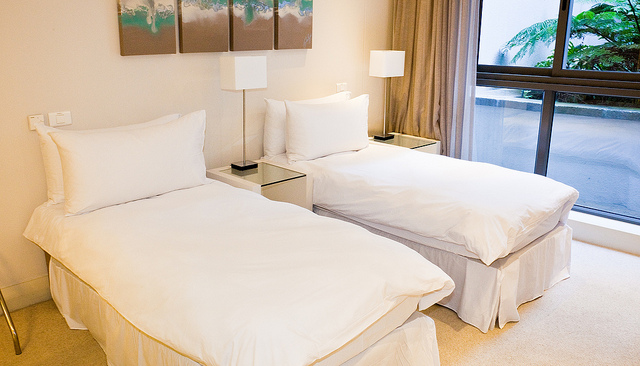Are there any signs of personal items or occupancy in this room? The room appears devoid of personal items, indicating it might be a display room, a hotel room awaiting guests, or simply a very tidy and unoccupied space. 